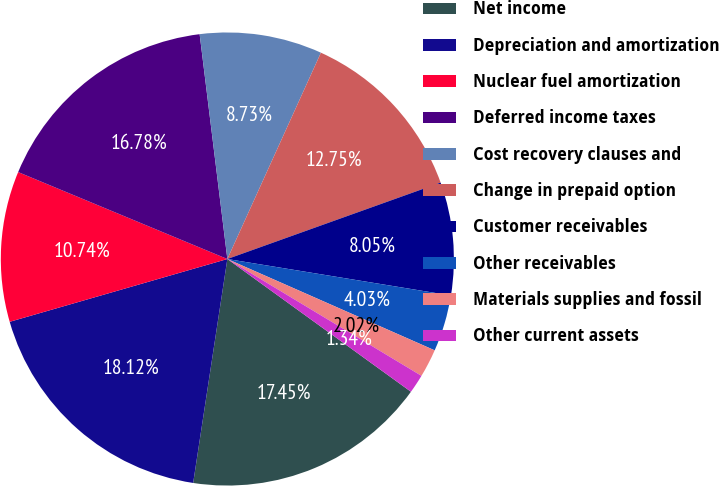Convert chart. <chart><loc_0><loc_0><loc_500><loc_500><pie_chart><fcel>Net income<fcel>Depreciation and amortization<fcel>Nuclear fuel amortization<fcel>Deferred income taxes<fcel>Cost recovery clauses and<fcel>Change in prepaid option<fcel>Customer receivables<fcel>Other receivables<fcel>Materials supplies and fossil<fcel>Other current assets<nl><fcel>17.45%<fcel>18.12%<fcel>10.74%<fcel>16.78%<fcel>8.73%<fcel>12.75%<fcel>8.05%<fcel>4.03%<fcel>2.02%<fcel>1.34%<nl></chart> 